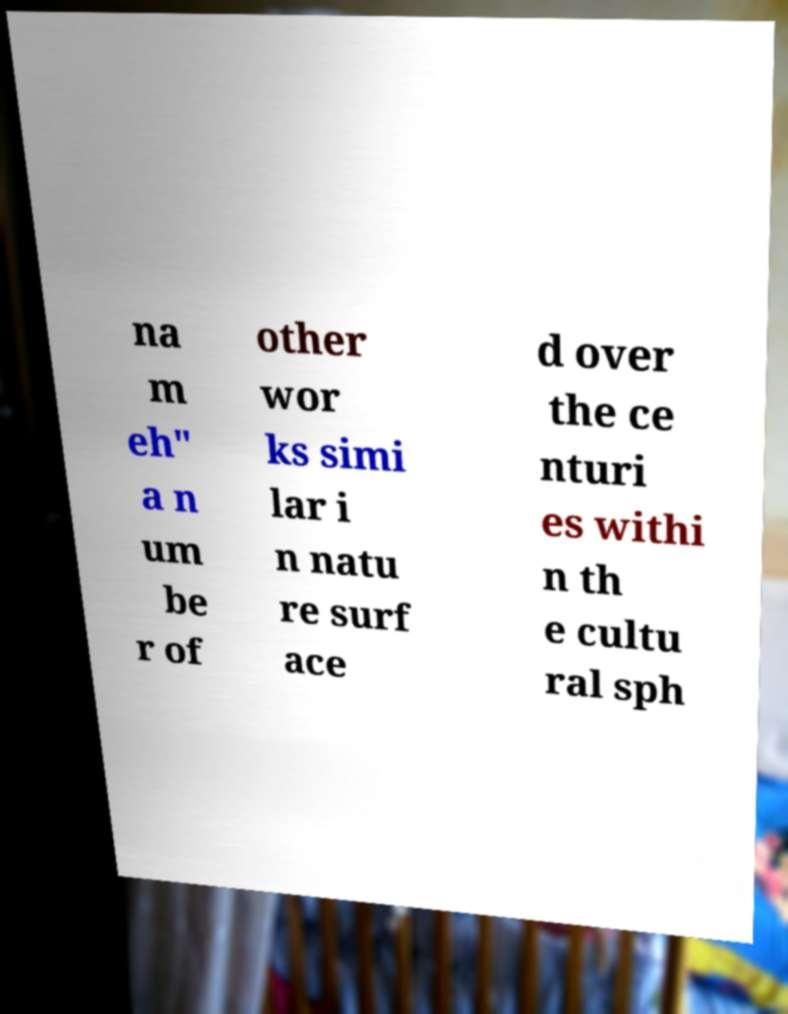I need the written content from this picture converted into text. Can you do that? na m eh" a n um be r of other wor ks simi lar i n natu re surf ace d over the ce nturi es withi n th e cultu ral sph 